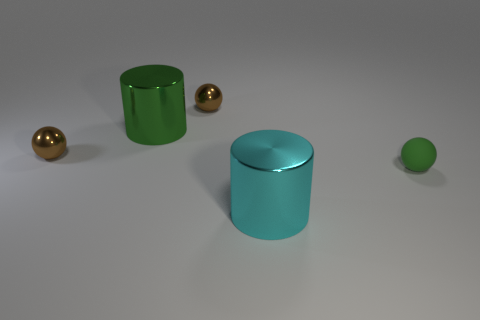What can you infer about the lighting of the scene? The lighting in the scene appears to be coming from above, casting soft shadows directly underneath the objects. The light source seems diffused, creating a gentle illumination across the setup without harsh shadows, suggesting an indoor setting with artificial lighting. 